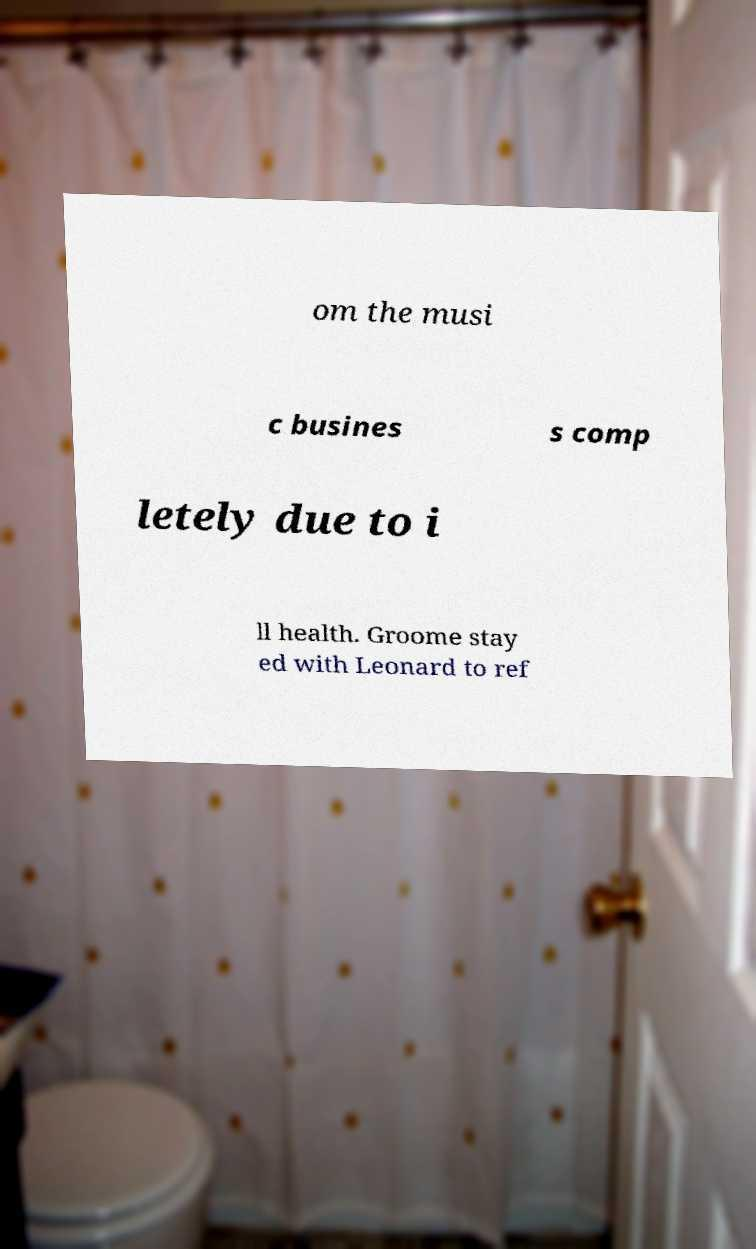What messages or text are displayed in this image? I need them in a readable, typed format. om the musi c busines s comp letely due to i ll health. Groome stay ed with Leonard to ref 